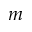<formula> <loc_0><loc_0><loc_500><loc_500>m</formula> 